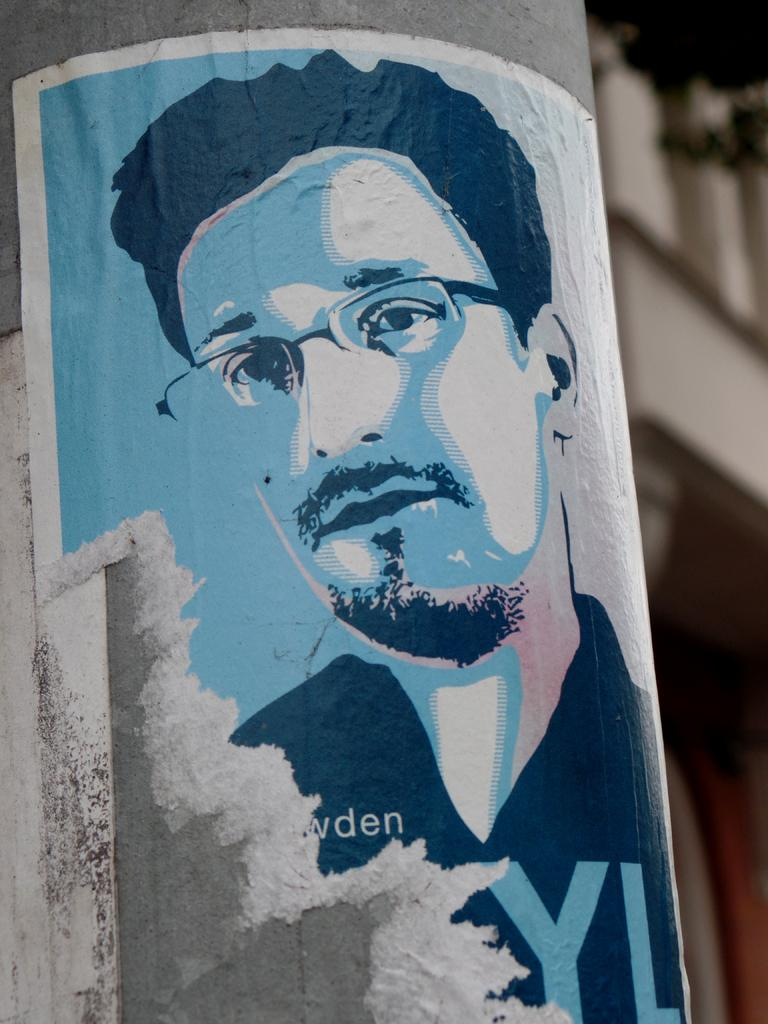What is present in the image that features an image of a person? There is a poster in the image that has an image of a person. How is the poster positioned in the image? The poster is attached to a pillar. Can you see any boats in the harbor in the image? There is no harbor or boats present in the image; it features a poster with a person's image attached to a pillar. 